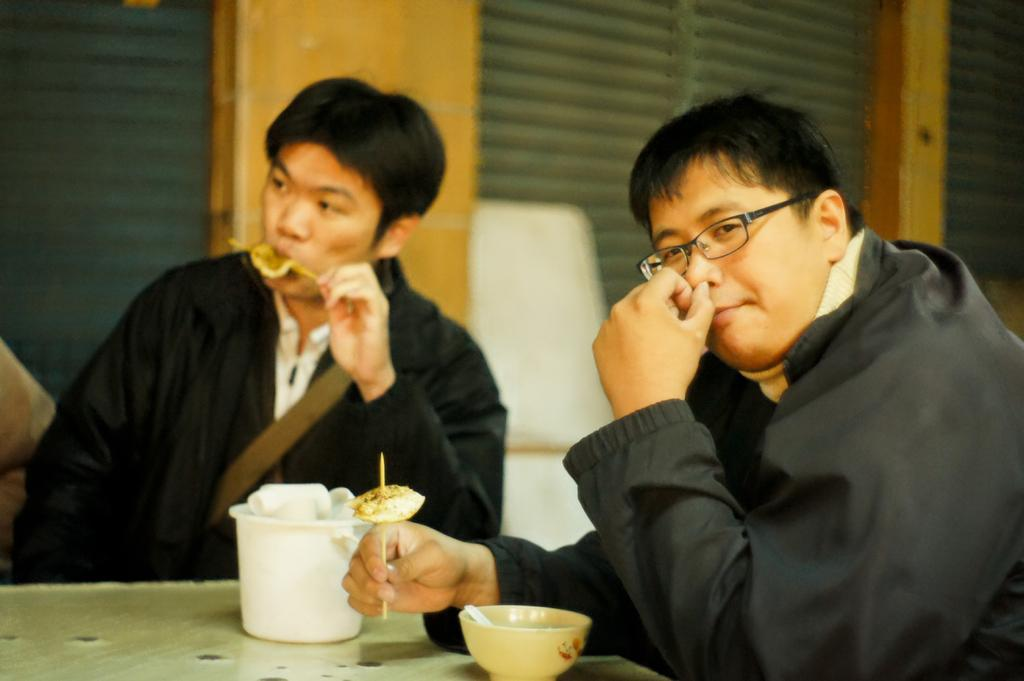How many people are in the foreground of the picture? There are two persons in the foreground of the picture. What is located in the foreground of the picture besides the people? There is a table in the foreground of the picture. What can be found on the table? There are bowls and food items on the table. What is visible in the background of the picture? There are windows in the background of the picture. What type of window treatment is present in the image? There are window blinds associated with the windows. How much money is being exchanged between the two persons in the image? There is no indication of money or any exchange taking place in the image. What type of sail can be seen in the background of the image? There is no sail present in the image; it features a table with bowls and food items, as well as windows in the background. 